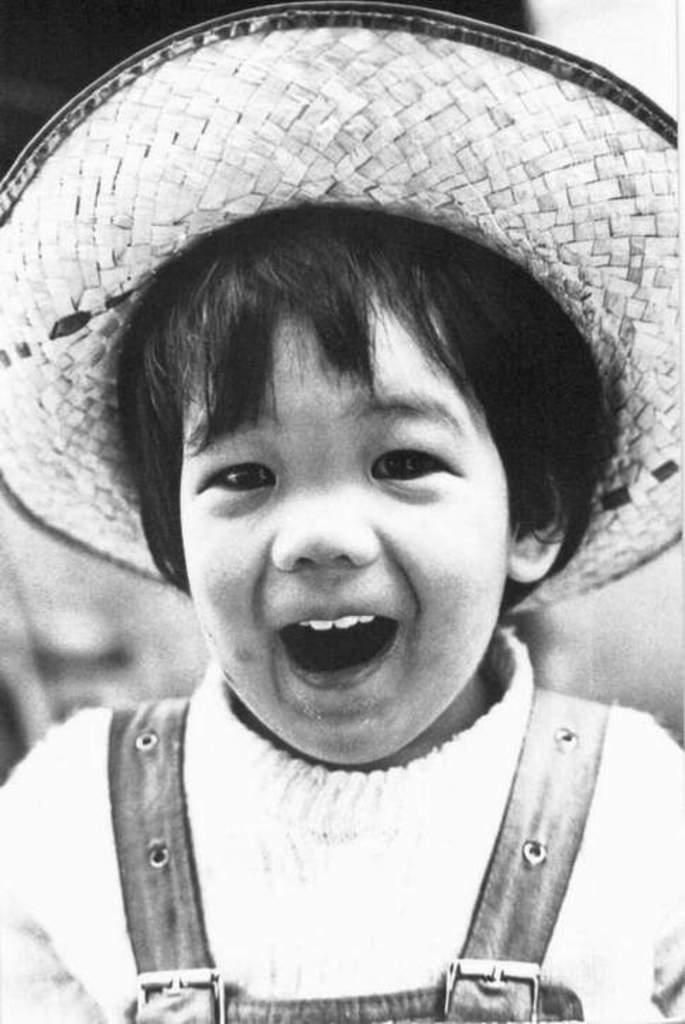What is the color scheme of the image? The image is black and white. What is the main subject in the image? There is a kid in the middle of the image. What is the kid wearing on their head? The kid is wearing a hat. What type of beetle can be seen crawling on the hat in the image? There is no beetle present in the image; the hat is not mentioned to have any insects on it. 